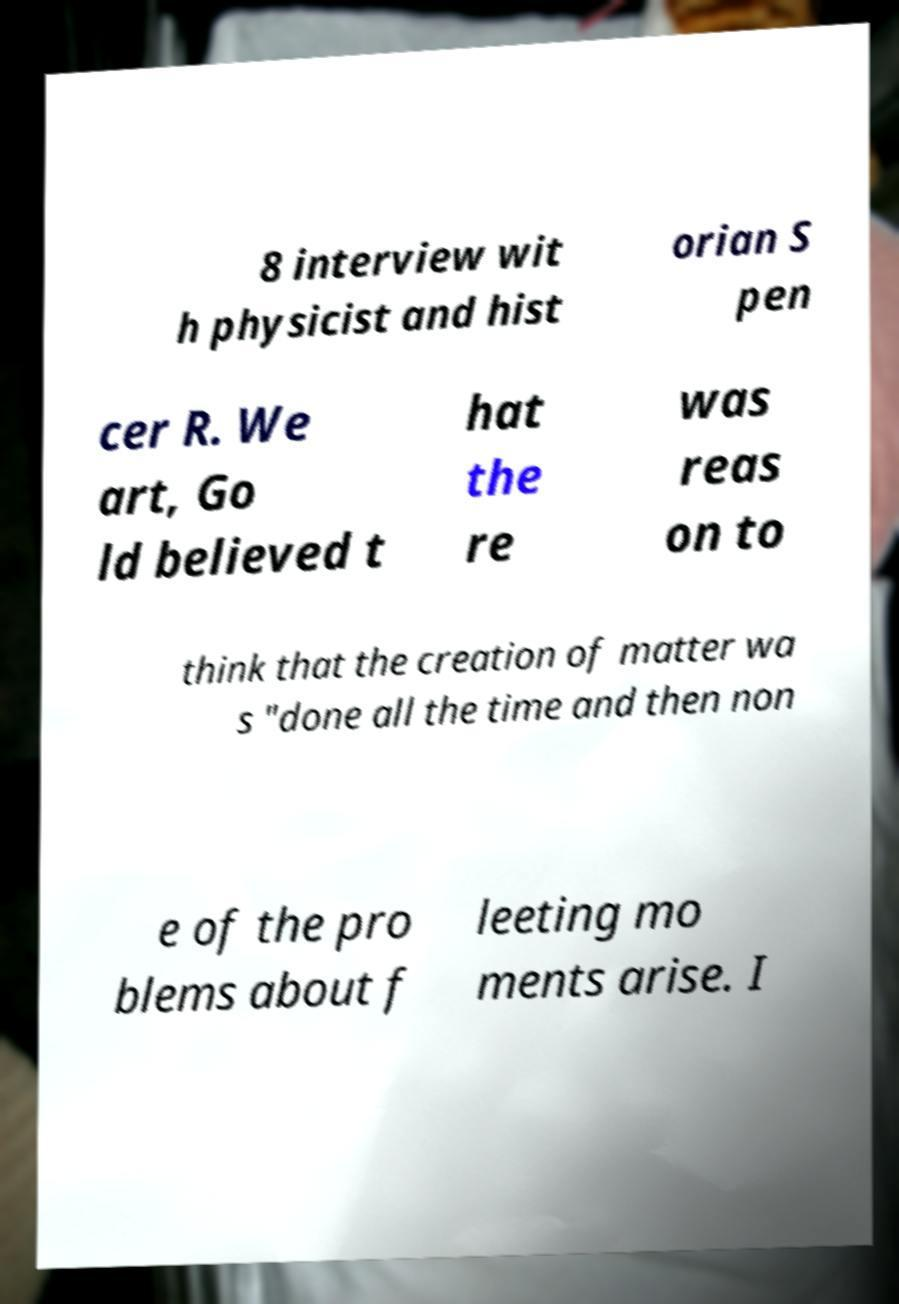Can you accurately transcribe the text from the provided image for me? 8 interview wit h physicist and hist orian S pen cer R. We art, Go ld believed t hat the re was reas on to think that the creation of matter wa s "done all the time and then non e of the pro blems about f leeting mo ments arise. I 